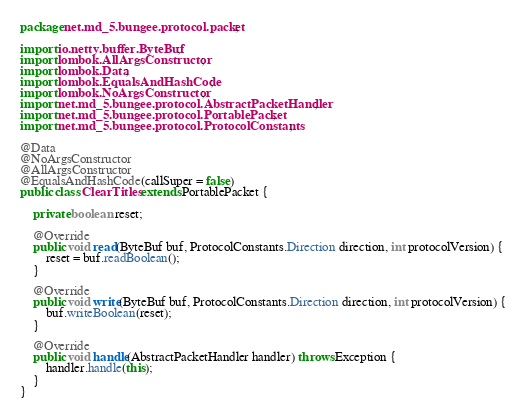<code> <loc_0><loc_0><loc_500><loc_500><_Java_>package net.md_5.bungee.protocol.packet;

import io.netty.buffer.ByteBuf;
import lombok.AllArgsConstructor;
import lombok.Data;
import lombok.EqualsAndHashCode;
import lombok.NoArgsConstructor;
import net.md_5.bungee.protocol.AbstractPacketHandler;
import net.md_5.bungee.protocol.PortablePacket;
import net.md_5.bungee.protocol.ProtocolConstants;

@Data
@NoArgsConstructor
@AllArgsConstructor
@EqualsAndHashCode(callSuper = false)
public class ClearTitles extends PortablePacket {

    private boolean reset;

    @Override
    public void read(ByteBuf buf, ProtocolConstants.Direction direction, int protocolVersion) {
        reset = buf.readBoolean();
    }

    @Override
    public void write(ByteBuf buf, ProtocolConstants.Direction direction, int protocolVersion) {
        buf.writeBoolean(reset);
    }

    @Override
    public void handle(AbstractPacketHandler handler) throws Exception {
        handler.handle(this);
    }
}
</code> 